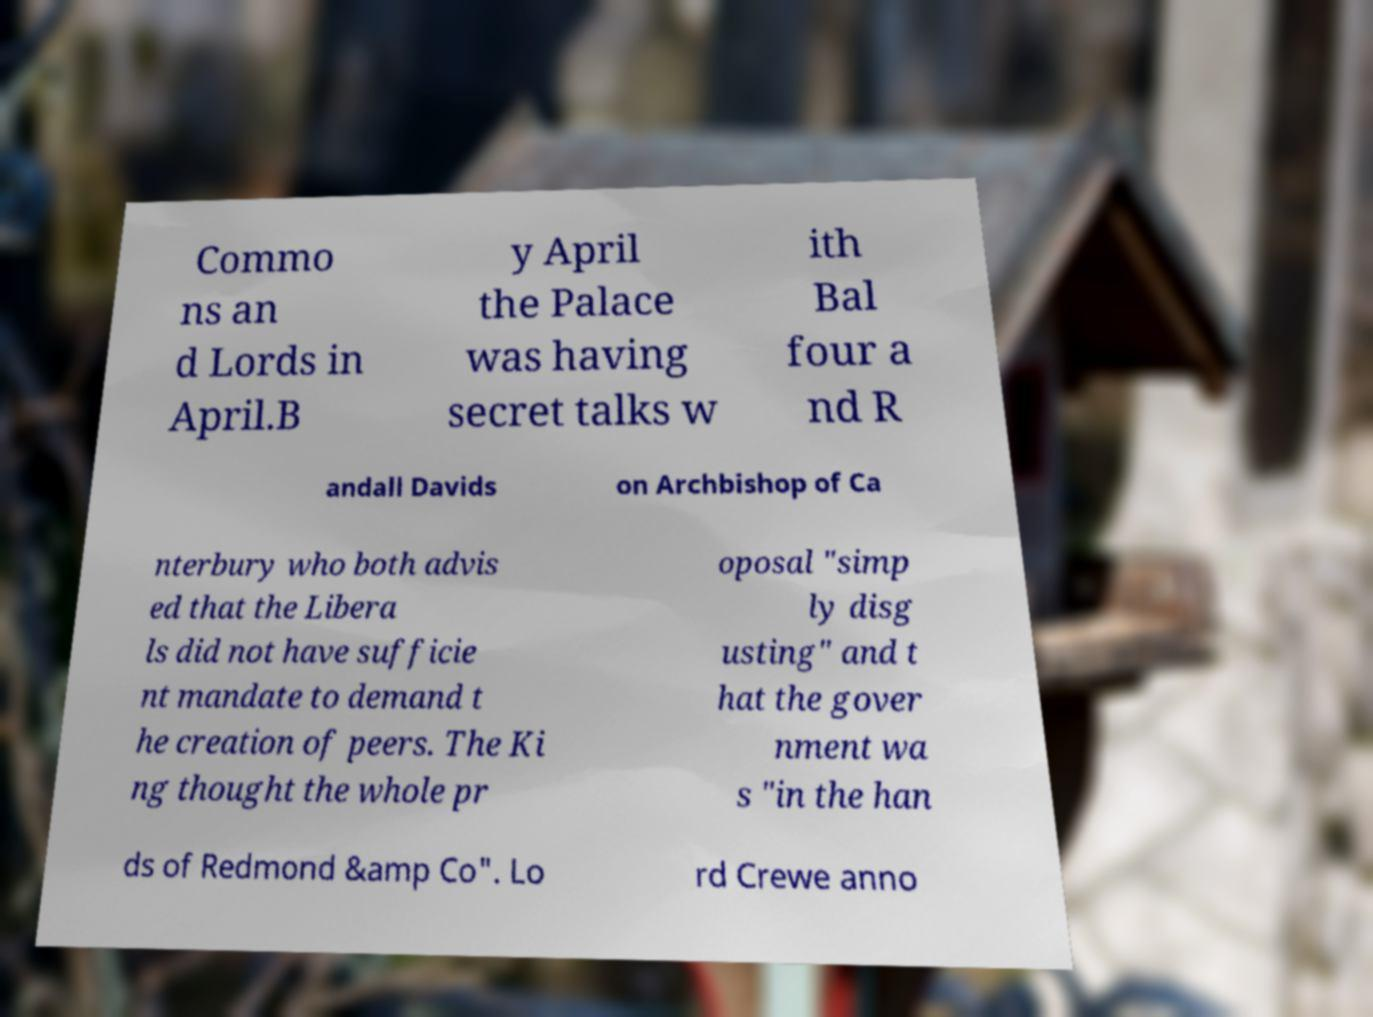Can you accurately transcribe the text from the provided image for me? Commo ns an d Lords in April.B y April the Palace was having secret talks w ith Bal four a nd R andall Davids on Archbishop of Ca nterbury who both advis ed that the Libera ls did not have sufficie nt mandate to demand t he creation of peers. The Ki ng thought the whole pr oposal "simp ly disg usting" and t hat the gover nment wa s "in the han ds of Redmond &amp Co". Lo rd Crewe anno 